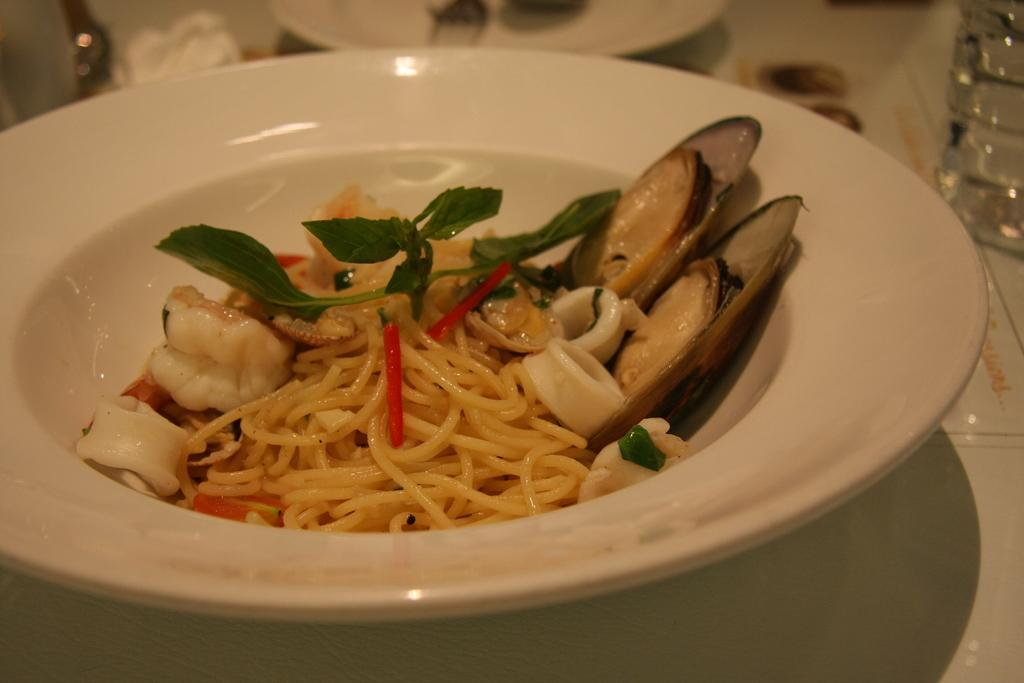What is on the plate that is visible in the image? There is food on a plate in the image. What else can be seen on the table in the image? There are objects on the table in the image. How many spoons are visible in the image? There are two spoons in the image. What is the bottle in the image used for? The purpose of the bottle in the image cannot be determined from the provided facts. Can you see any deer in the image? No, there are no deer present in the image. What type of competition is taking place in the image? There is no competition present in the image. 